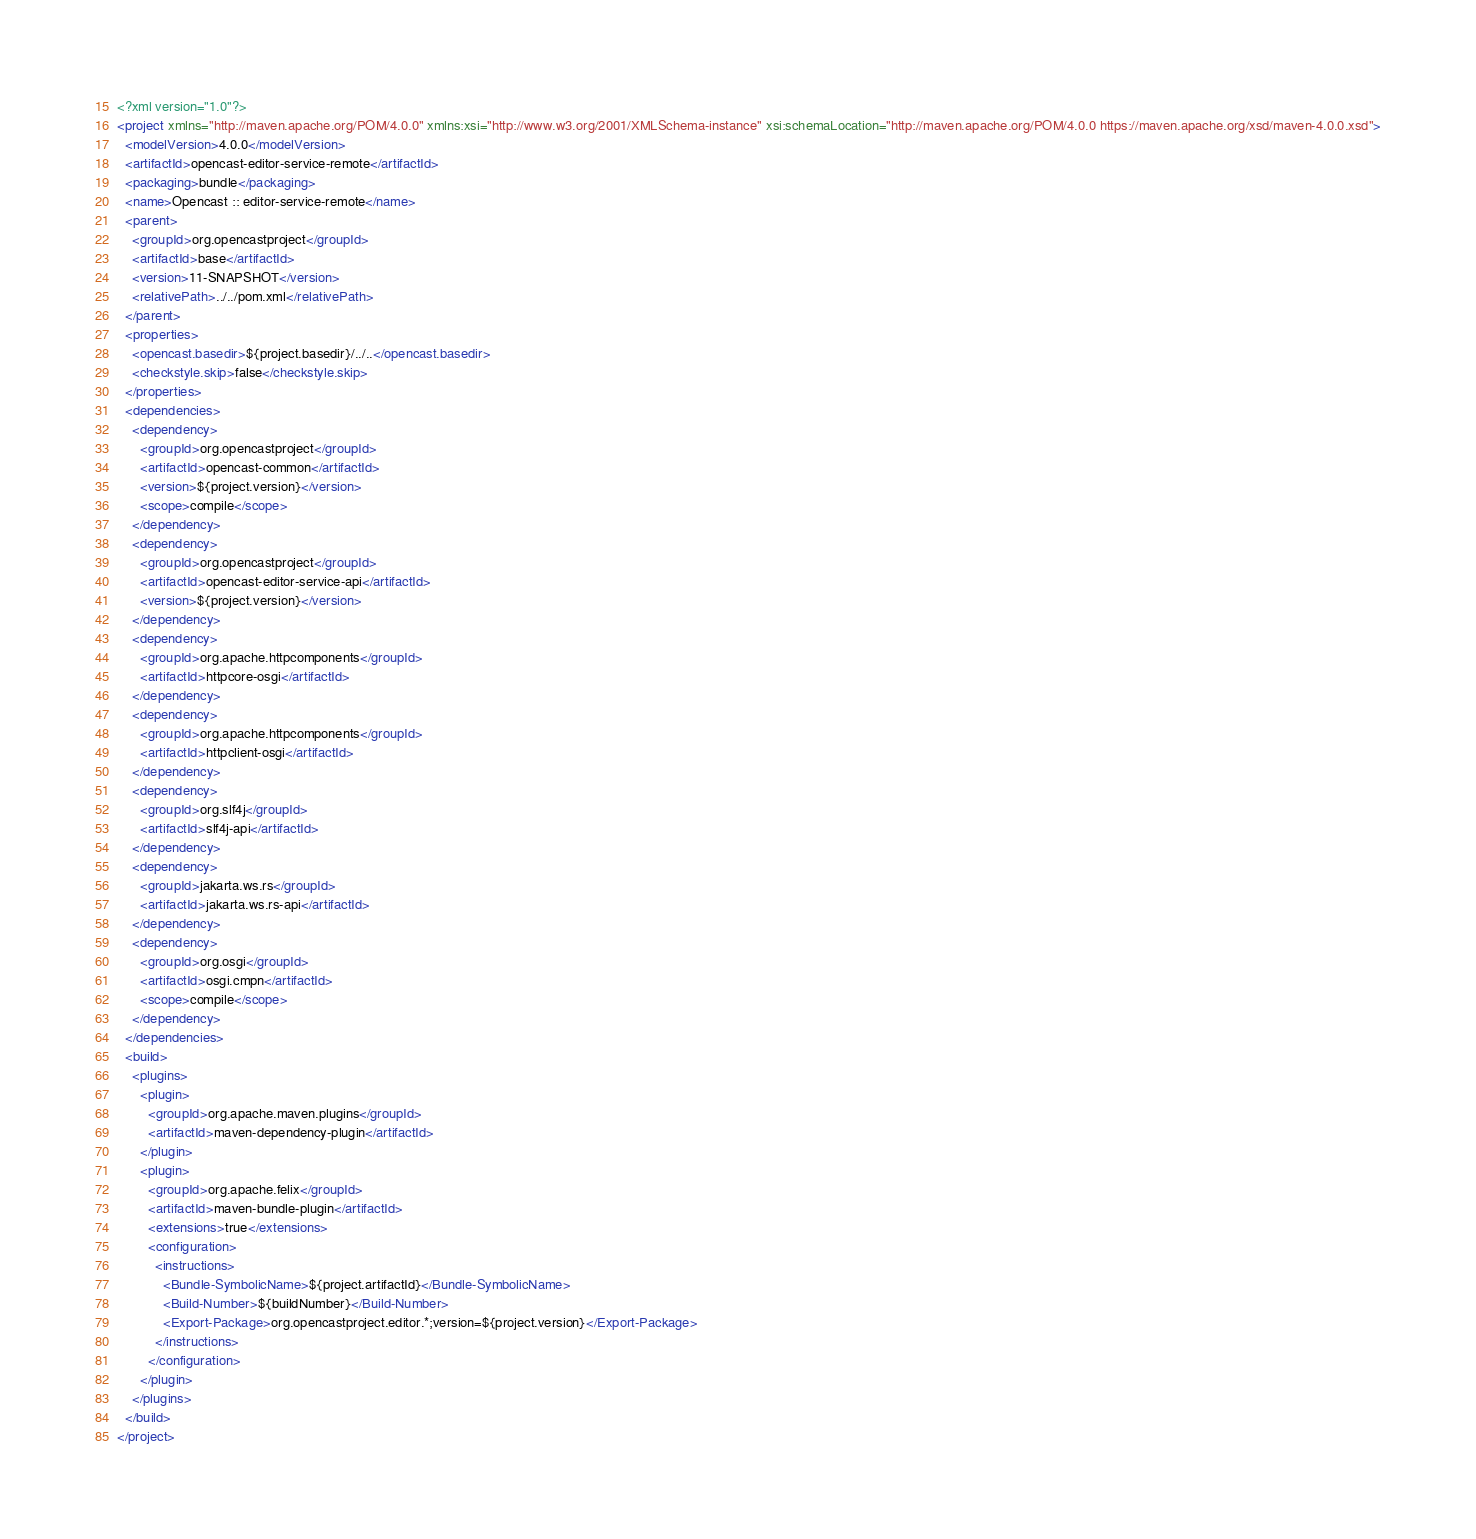<code> <loc_0><loc_0><loc_500><loc_500><_XML_><?xml version="1.0"?>
<project xmlns="http://maven.apache.org/POM/4.0.0" xmlns:xsi="http://www.w3.org/2001/XMLSchema-instance" xsi:schemaLocation="http://maven.apache.org/POM/4.0.0 https://maven.apache.org/xsd/maven-4.0.0.xsd">
  <modelVersion>4.0.0</modelVersion>
  <artifactId>opencast-editor-service-remote</artifactId>
  <packaging>bundle</packaging>
  <name>Opencast :: editor-service-remote</name>
  <parent>
    <groupId>org.opencastproject</groupId>
    <artifactId>base</artifactId>
    <version>11-SNAPSHOT</version>
    <relativePath>../../pom.xml</relativePath>
  </parent>
  <properties>
    <opencast.basedir>${project.basedir}/../..</opencast.basedir>
    <checkstyle.skip>false</checkstyle.skip>
  </properties>
  <dependencies>
    <dependency>
      <groupId>org.opencastproject</groupId>
      <artifactId>opencast-common</artifactId>
      <version>${project.version}</version>
      <scope>compile</scope>
    </dependency>
    <dependency>
      <groupId>org.opencastproject</groupId>
      <artifactId>opencast-editor-service-api</artifactId>
      <version>${project.version}</version>
    </dependency>
    <dependency>
      <groupId>org.apache.httpcomponents</groupId>
      <artifactId>httpcore-osgi</artifactId>
    </dependency>
    <dependency>
      <groupId>org.apache.httpcomponents</groupId>
      <artifactId>httpclient-osgi</artifactId>
    </dependency>
    <dependency>
      <groupId>org.slf4j</groupId>
      <artifactId>slf4j-api</artifactId>
    </dependency>
    <dependency>
      <groupId>jakarta.ws.rs</groupId>
      <artifactId>jakarta.ws.rs-api</artifactId>
    </dependency>
    <dependency>
      <groupId>org.osgi</groupId>
      <artifactId>osgi.cmpn</artifactId>
      <scope>compile</scope>
    </dependency>
  </dependencies>
  <build>
    <plugins>
      <plugin>
        <groupId>org.apache.maven.plugins</groupId>
        <artifactId>maven-dependency-plugin</artifactId>
      </plugin>
      <plugin>
        <groupId>org.apache.felix</groupId>
        <artifactId>maven-bundle-plugin</artifactId>
        <extensions>true</extensions>
        <configuration>
          <instructions>
            <Bundle-SymbolicName>${project.artifactId}</Bundle-SymbolicName>
            <Build-Number>${buildNumber}</Build-Number>
            <Export-Package>org.opencastproject.editor.*;version=${project.version}</Export-Package>
          </instructions>
        </configuration>
      </plugin>
    </plugins>
  </build>
</project>
</code> 